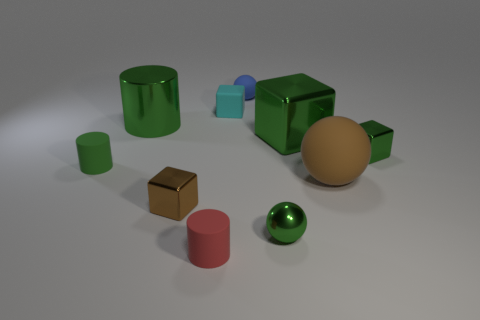Subtract all gray blocks. Subtract all green cylinders. How many blocks are left? 4 Subtract all cylinders. How many objects are left? 7 Add 1 green spheres. How many green spheres are left? 2 Add 1 yellow things. How many yellow things exist? 1 Subtract 1 green balls. How many objects are left? 9 Subtract all tiny blue cylinders. Subtract all green spheres. How many objects are left? 9 